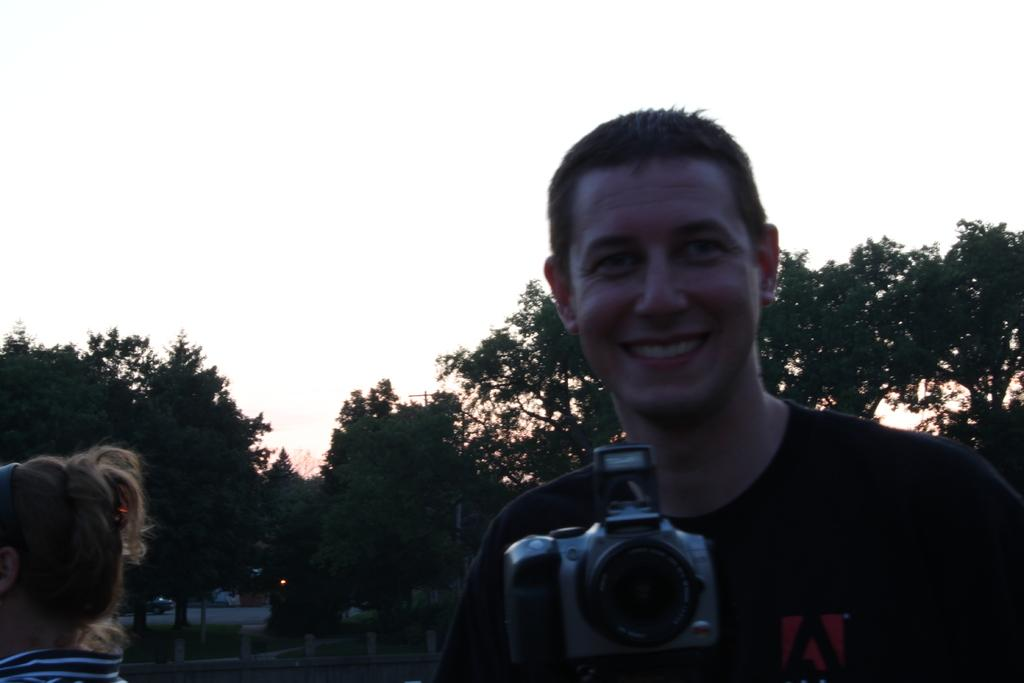What is the man in the image doing? The man is standing and smiling in the image. What is the man holding in his hand? The man is holding a camera in his hand. Who else is present in the image besides the man? There is a girl in the image. What can be seen in the background of the image? Trees and the sky are visible in the background of the image. What type of view does the man have of his crush in the image? There is no mention of a crush in the image, so it is not possible to determine the man's view of a crush. 